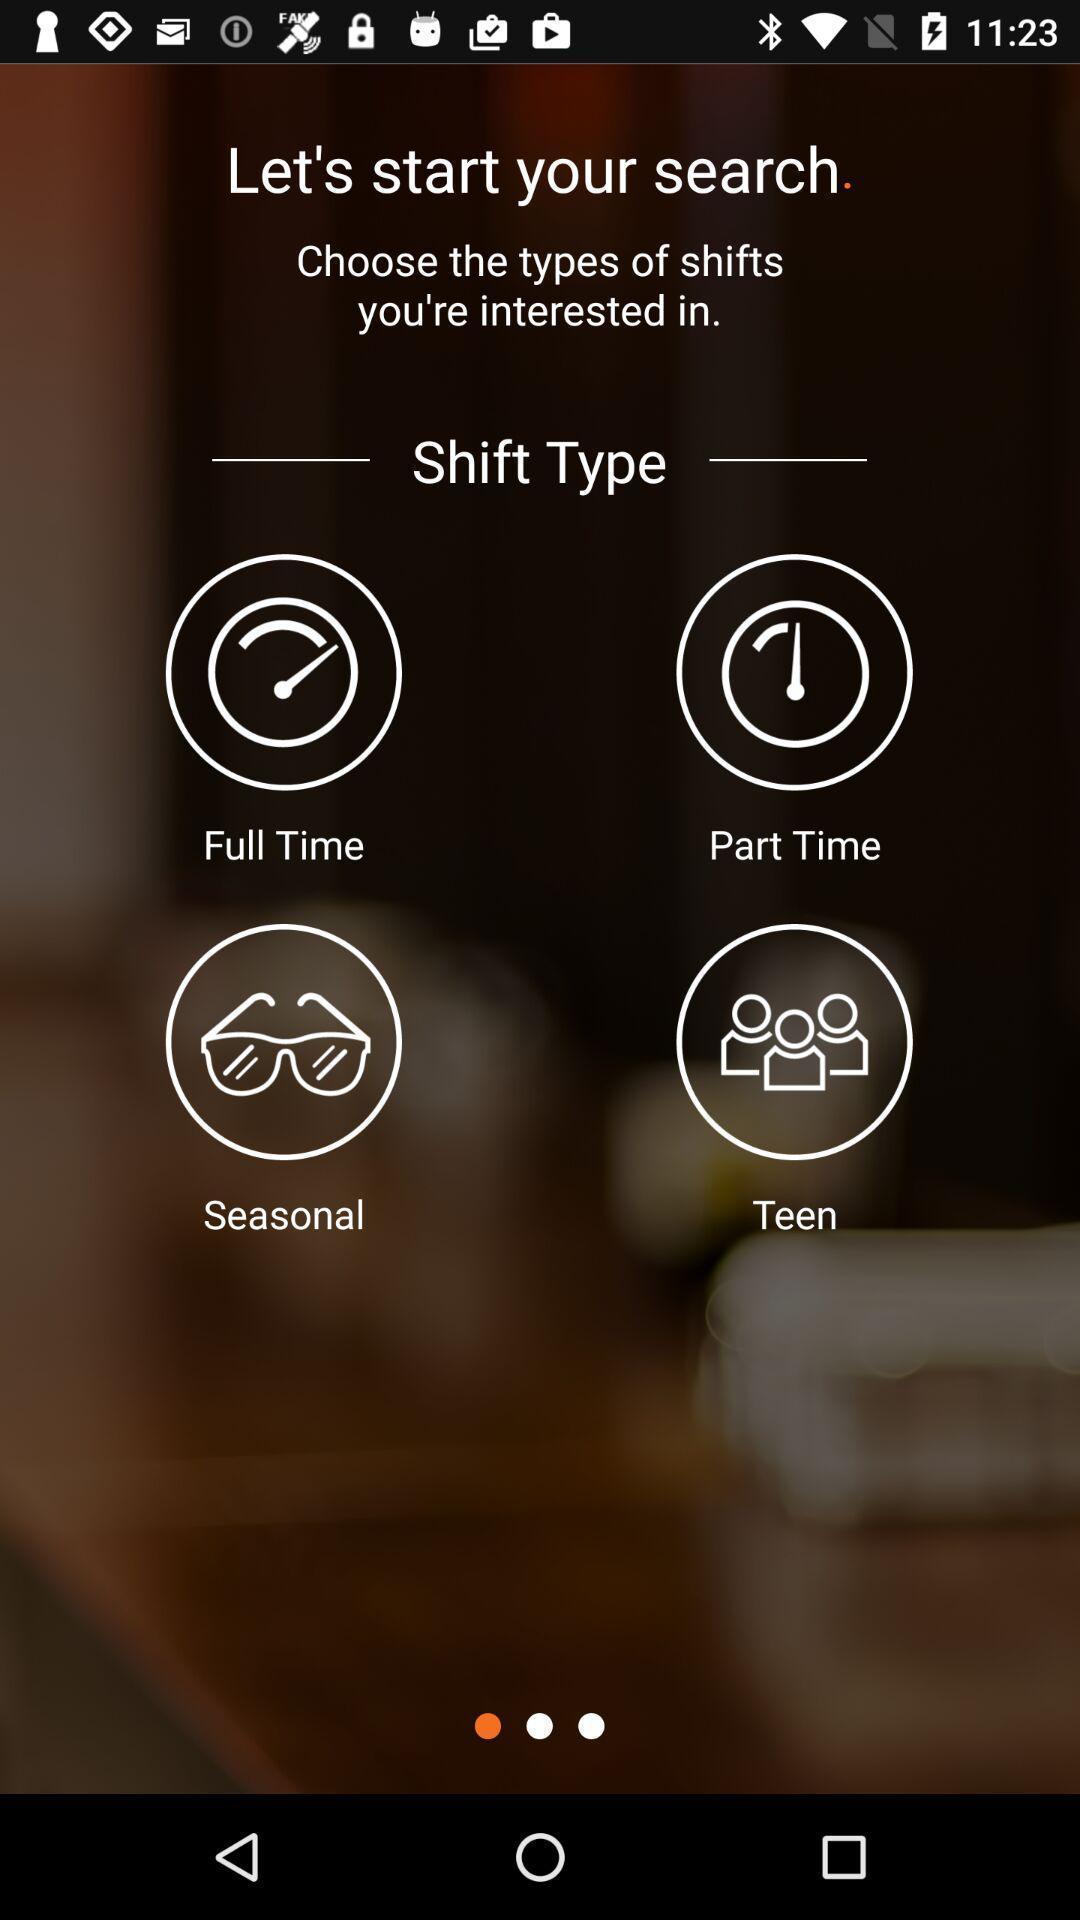Describe the content in this image. Screen displaying the start page with multiple shift options. 